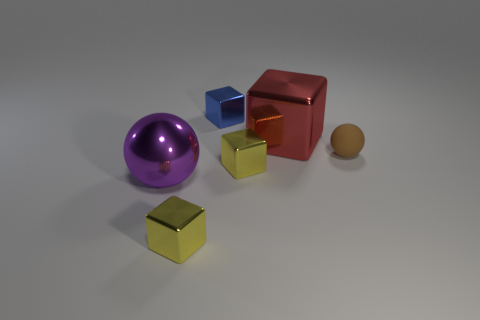Are there any big red cylinders made of the same material as the red cube?
Keep it short and to the point. No. Does the big metallic object that is behind the small rubber object have the same shape as the tiny blue object?
Make the answer very short. Yes. What number of tiny shiny things are left of the big thing that is right of the tiny shiny cube that is behind the brown rubber thing?
Offer a very short reply. 3. Are there fewer small metallic objects that are in front of the purple thing than objects in front of the brown rubber thing?
Your answer should be very brief. Yes. What color is the big metal thing that is the same shape as the small blue metallic thing?
Provide a succinct answer. Red. What size is the brown sphere?
Ensure brevity in your answer.  Small. How many brown rubber things have the same size as the red shiny thing?
Provide a short and direct response. 0. Is the block behind the large red block made of the same material as the sphere that is left of the big metal cube?
Your response must be concise. Yes. Are there more red shiny cubes than tiny brown metal cylinders?
Provide a succinct answer. Yes. Is there anything else that is the same color as the large shiny sphere?
Ensure brevity in your answer.  No. 